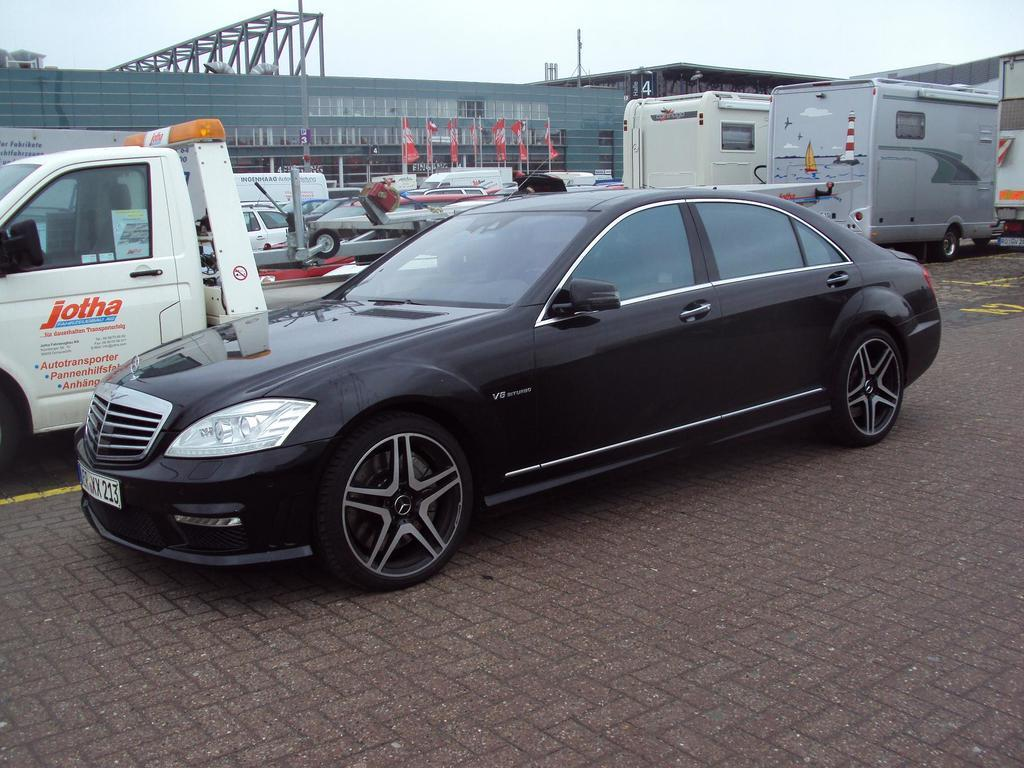What is happening on the road in the image? There are vehicles on the road in the image. What can be seen in the background of the image? There are flags and buildings in the background of the image. What is visible in the sky in the image? The sky is visible in the background of the image. What type of cork can be seen floating in the sky in the image? There is no cork present in the image, and the sky is visible, not a body of water where a cork might float. 